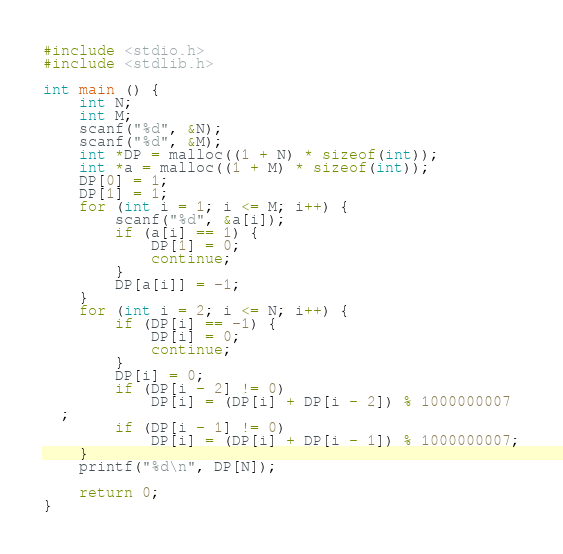<code> <loc_0><loc_0><loc_500><loc_500><_C_>#include <stdio.h>
#include <stdlib.h>

int main () {
    int N;
    int M;
    scanf("%d", &N);
    scanf("%d", &M);
    int *DP = malloc((1 + N) * sizeof(int));
    int *a = malloc((1 + M) * sizeof(int));
    DP[0] = 1;
    DP[1] = 1;
    for (int i = 1; i <= M; i++) {
        scanf("%d", &a[i]);
        if (a[i] == 1) {
            DP[1] = 0;
            continue;
        }
        DP[a[i]] = -1;
    }
    for (int i = 2; i <= N; i++) {
        if (DP[i] == -1) {
            DP[i] = 0;
            continue;
        }
        DP[i] = 0;
        if (DP[i - 2] != 0)
            DP[i] = (DP[i] + DP[i - 2]) % 1000000007
  ;
        if (DP[i - 1] != 0)
            DP[i] = (DP[i] + DP[i - 1]) % 1000000007;
    }
    printf("%d\n", DP[N]);

    return 0;
}

</code> 